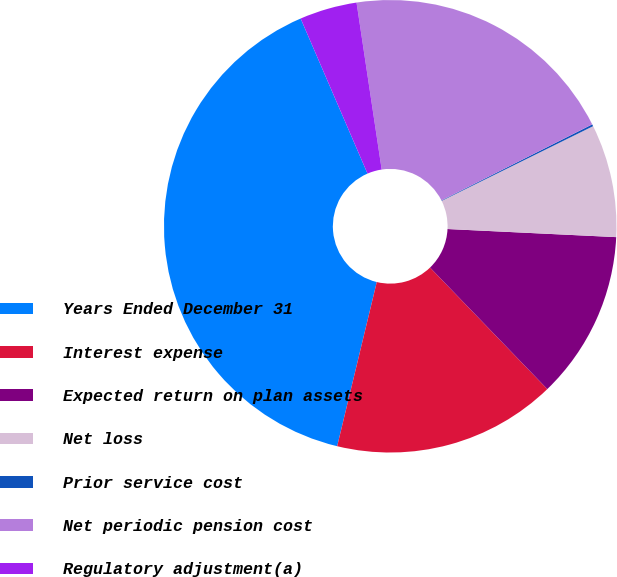<chart> <loc_0><loc_0><loc_500><loc_500><pie_chart><fcel>Years Ended December 31<fcel>Interest expense<fcel>Expected return on plan assets<fcel>Net loss<fcel>Prior service cost<fcel>Net periodic pension cost<fcel>Regulatory adjustment(a)<nl><fcel>39.75%<fcel>15.98%<fcel>12.02%<fcel>8.06%<fcel>0.14%<fcel>19.94%<fcel>4.1%<nl></chart> 